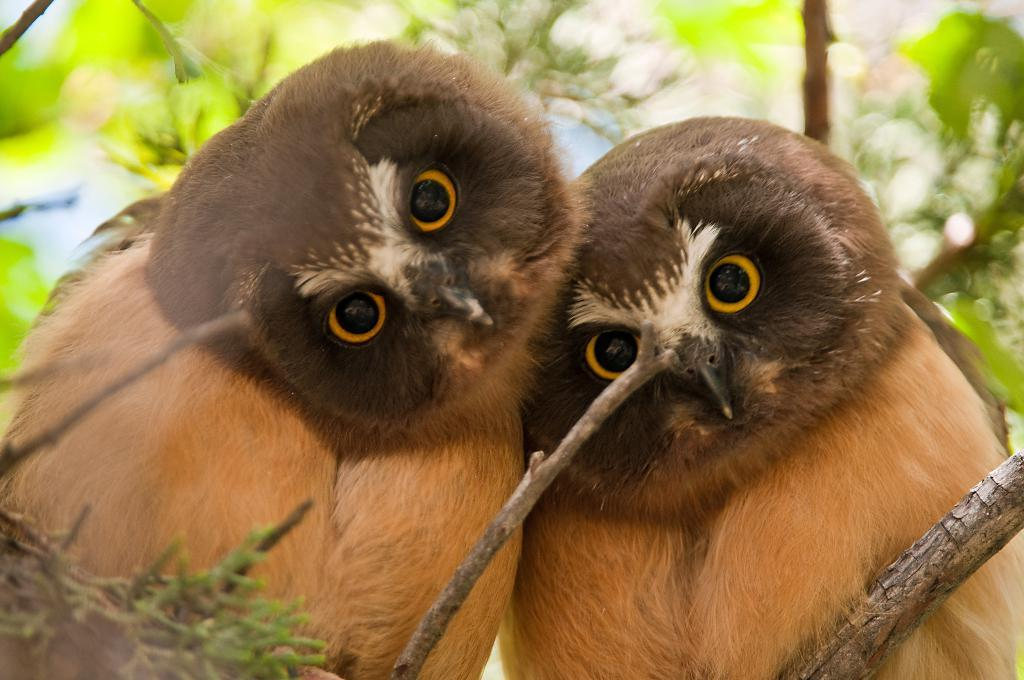How many owls are in the image? There are two owls in the image. Where are the owls located? The owls are sitting on a branch of a tree. What else can be seen in the image besides the owls? There are stems visible in the image. What is visible in the background of the image? There are leaves of a tree in the background of the image. What color is the sheet draped over the donkey in the image? There is no donkey or sheet present in the image; it features two owls sitting on a branch of a tree. 